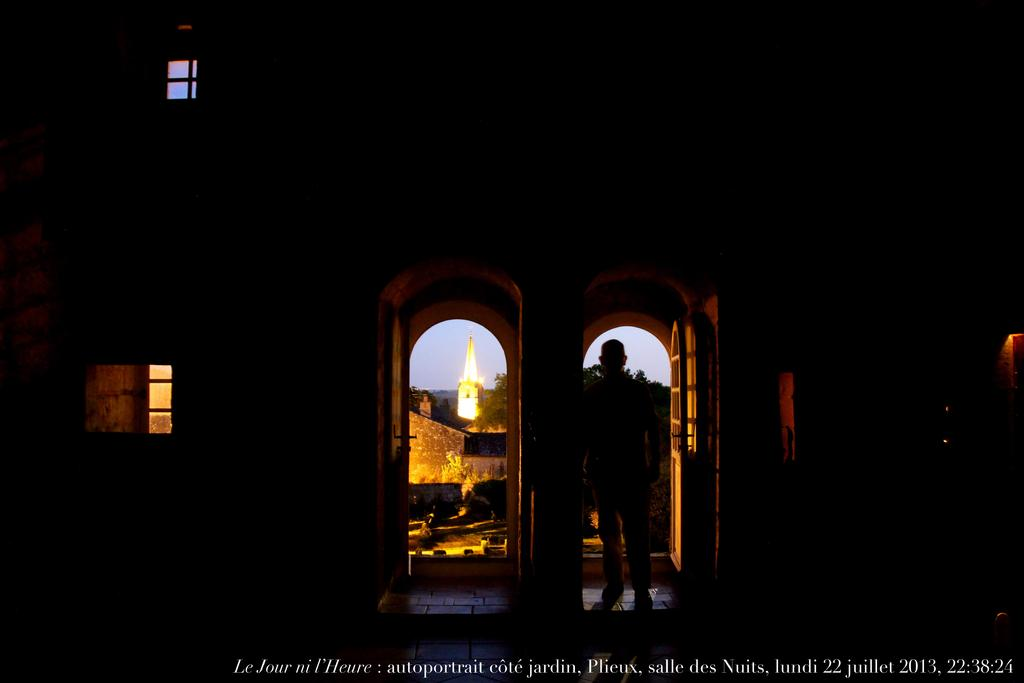What type of structure is visible in the image? The image contains a wall. What features can be seen on the wall? The wall has windows and doors. Is there anyone present in the image? Yes, there is a person in the middle of the image. What is located at the bottom of the image? There is text at the bottom of the image. What type of guitar is the person playing in the image? There is no guitar present in the image; the person is not playing any instrument. 